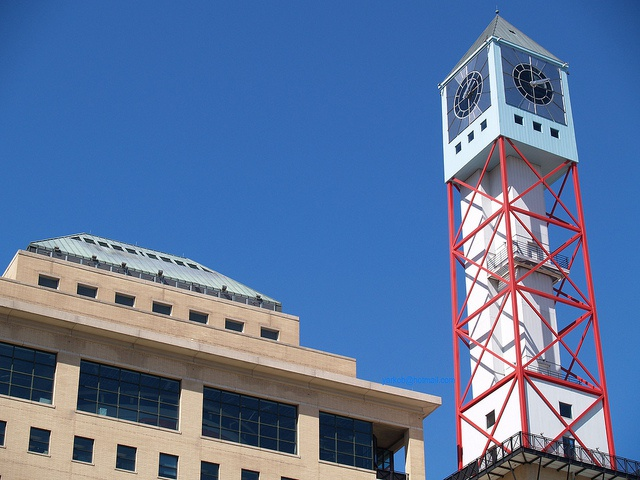Describe the objects in this image and their specific colors. I can see clock in blue, black, and gray tones and clock in blue, gray, navy, and darkgray tones in this image. 